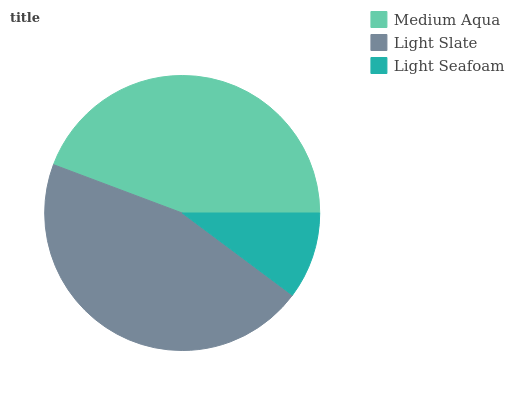Is Light Seafoam the minimum?
Answer yes or no. Yes. Is Light Slate the maximum?
Answer yes or no. Yes. Is Light Slate the minimum?
Answer yes or no. No. Is Light Seafoam the maximum?
Answer yes or no. No. Is Light Slate greater than Light Seafoam?
Answer yes or no. Yes. Is Light Seafoam less than Light Slate?
Answer yes or no. Yes. Is Light Seafoam greater than Light Slate?
Answer yes or no. No. Is Light Slate less than Light Seafoam?
Answer yes or no. No. Is Medium Aqua the high median?
Answer yes or no. Yes. Is Medium Aqua the low median?
Answer yes or no. Yes. Is Light Seafoam the high median?
Answer yes or no. No. Is Light Slate the low median?
Answer yes or no. No. 